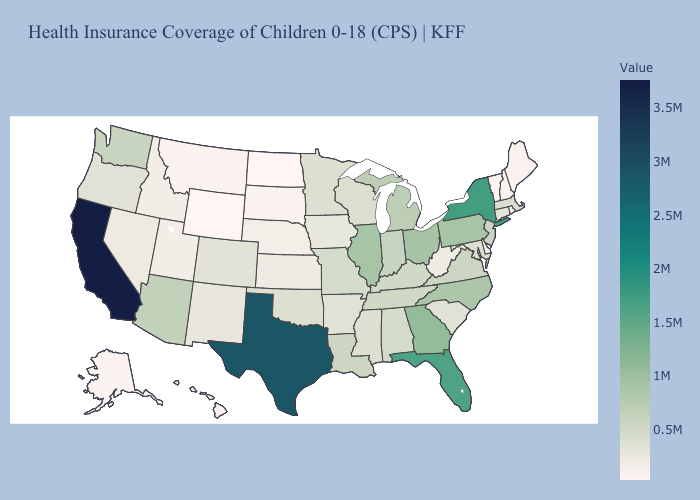Does Florida have a lower value than Hawaii?
Quick response, please. No. Among the states that border Illinois , which have the highest value?
Write a very short answer. Indiana. Does California have the highest value in the USA?
Give a very brief answer. Yes. Is the legend a continuous bar?
Quick response, please. Yes. 